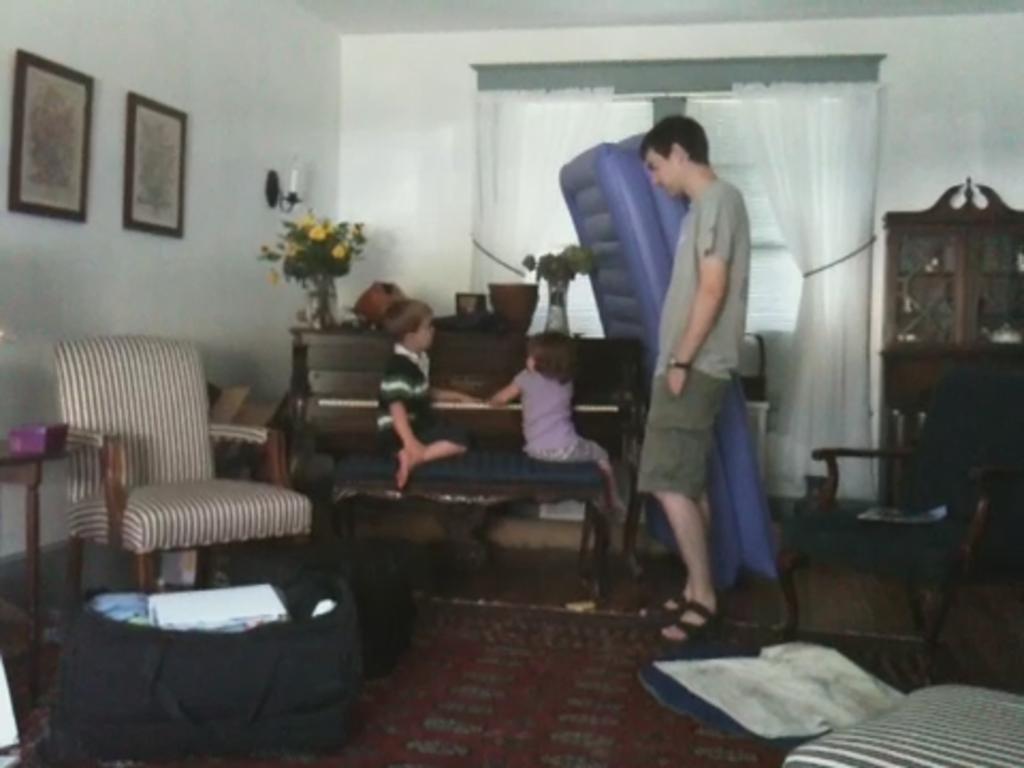In one or two sentences, can you explain what this image depicts? A boy and a girl are playing with a piano. A man is standing beside them. 